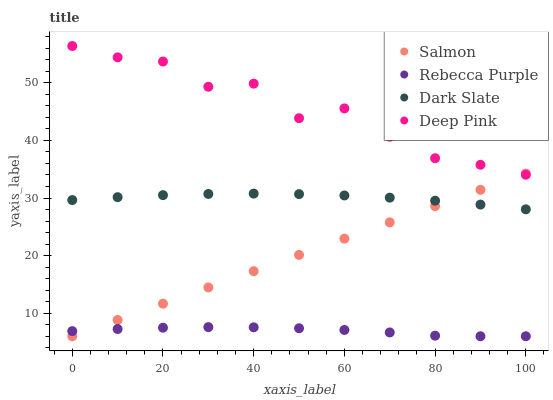Does Rebecca Purple have the minimum area under the curve?
Answer yes or no. Yes. Does Deep Pink have the maximum area under the curve?
Answer yes or no. Yes. Does Salmon have the minimum area under the curve?
Answer yes or no. No. Does Salmon have the maximum area under the curve?
Answer yes or no. No. Is Salmon the smoothest?
Answer yes or no. Yes. Is Deep Pink the roughest?
Answer yes or no. Yes. Is Deep Pink the smoothest?
Answer yes or no. No. Is Salmon the roughest?
Answer yes or no. No. Does Salmon have the lowest value?
Answer yes or no. Yes. Does Deep Pink have the lowest value?
Answer yes or no. No. Does Deep Pink have the highest value?
Answer yes or no. Yes. Does Salmon have the highest value?
Answer yes or no. No. Is Rebecca Purple less than Dark Slate?
Answer yes or no. Yes. Is Dark Slate greater than Rebecca Purple?
Answer yes or no. Yes. Does Dark Slate intersect Salmon?
Answer yes or no. Yes. Is Dark Slate less than Salmon?
Answer yes or no. No. Is Dark Slate greater than Salmon?
Answer yes or no. No. Does Rebecca Purple intersect Dark Slate?
Answer yes or no. No. 